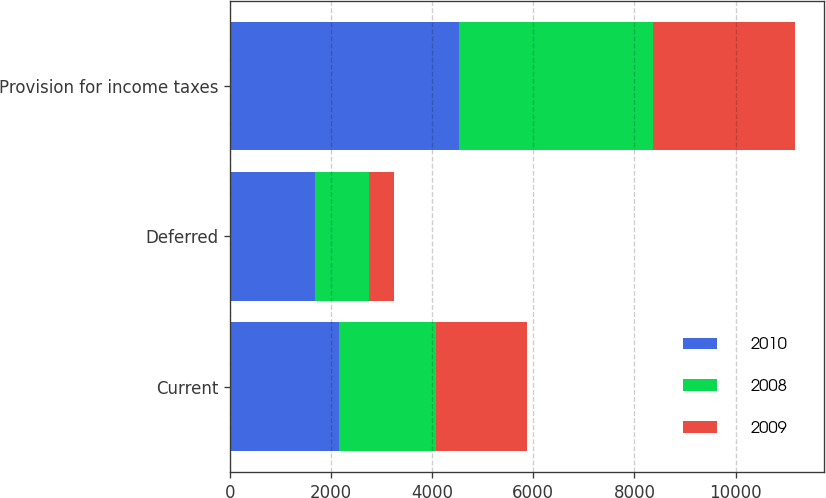Convert chart. <chart><loc_0><loc_0><loc_500><loc_500><stacked_bar_chart><ecel><fcel>Current<fcel>Deferred<fcel>Provision for income taxes<nl><fcel>2010<fcel>2150<fcel>1676<fcel>4527<nl><fcel>2008<fcel>1922<fcel>1077<fcel>3831<nl><fcel>2009<fcel>1796<fcel>498<fcel>2828<nl></chart> 